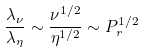<formula> <loc_0><loc_0><loc_500><loc_500>\frac { \lambda _ { \nu } } { \lambda _ { \eta } } \sim \frac { \nu ^ { 1 / 2 } } { \eta ^ { 1 / 2 } } \sim P _ { r } ^ { 1 / 2 }</formula> 